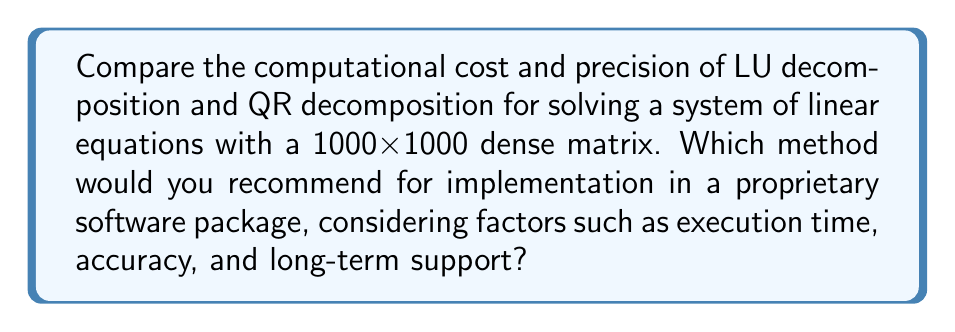Can you solve this math problem? To compare LU and QR decomposition methods, we need to consider their computational complexity and numerical stability:

1. Computational Cost:
   a) LU decomposition:
      - Requires approximately $\frac{2}{3}n^3$ floating-point operations for an $n \times n$ matrix
      - For a 1000x1000 matrix: $\frac{2}{3} \cdot 1000^3 \approx 6.67 \times 10^8$ operations

   b) QR decomposition (using Householder reflections):
      - Requires approximately $\frac{4}{3}n^3$ floating-point operations for an $n \times n$ matrix
      - For a 1000x1000 matrix: $\frac{4}{3} \cdot 1000^3 \approx 1.33 \times 10^9$ operations

2. Precision and Stability:
   a) LU decomposition:
      - Can be unstable for ill-conditioned matrices
      - May require pivoting to improve stability, which adds complexity
      - Accuracy can degrade for large systems or poorly conditioned matrices

   b) QR decomposition:
      - Generally more stable than LU decomposition
      - Does not require pivoting
      - Maintains better accuracy for ill-conditioned matrices

3. Implementation and Support:
   a) LU decomposition:
      - Simpler to implement
      - Well-established in many proprietary software packages
      - Easier to maintain and support due to its widespread use

   b) QR decomposition:
      - More complex to implement
      - Less common in legacy systems
      - May require more specialized knowledge for long-term support

Considering these factors, the recommendation would be to implement LU decomposition in a proprietary software package for the following reasons:

1. Lower computational cost (about half that of QR decomposition)
2. Simpler implementation and maintenance
3. Wider availability of support and documentation
4. Adequate precision for most well-conditioned systems

However, it's important to include pivoting in the LU decomposition implementation to improve stability. For cases where higher precision is required or when dealing with ill-conditioned matrices, QR decomposition should be offered as an alternative method.
Answer: LU decomposition with pivoting, due to lower computational cost and easier long-term support. 